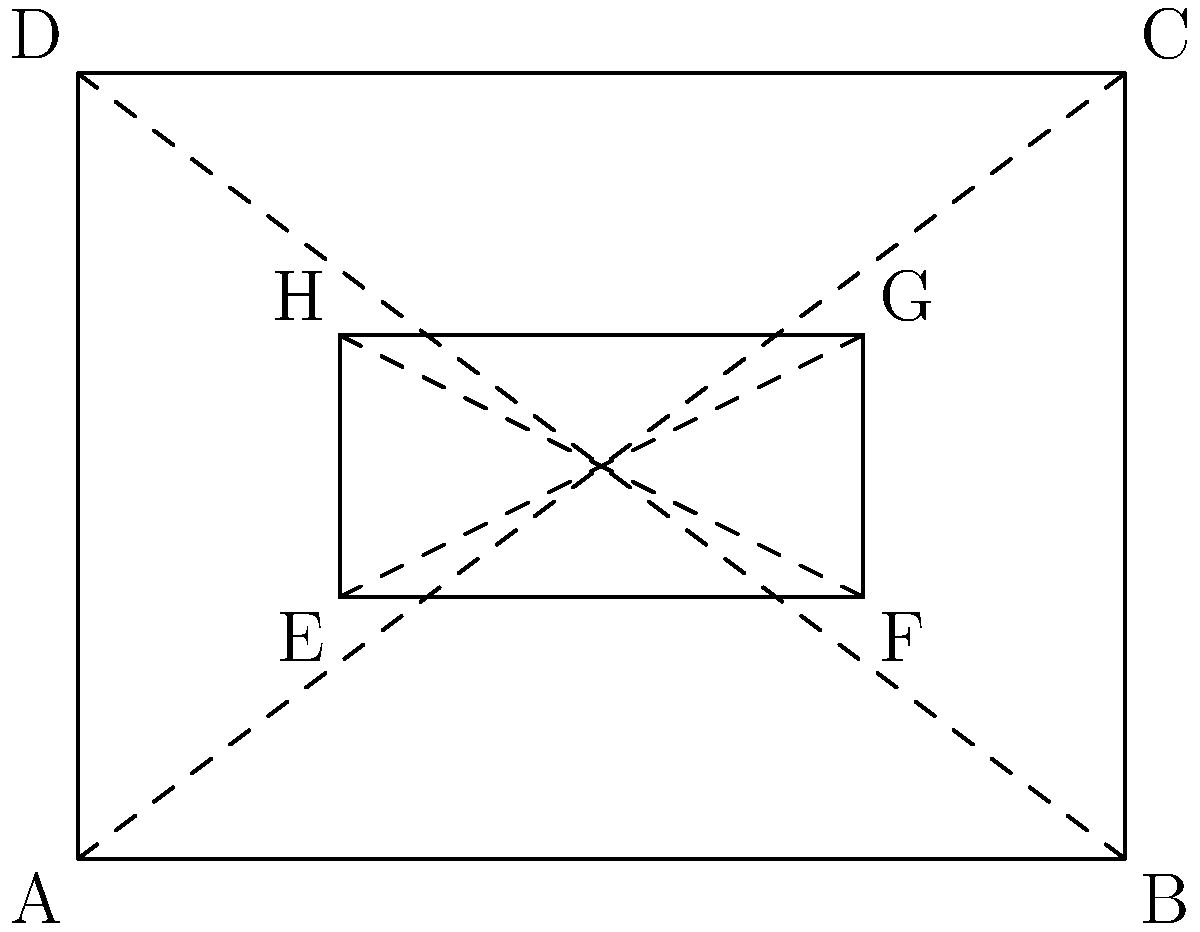In a still life composition, you've arranged two rectangular canvases as shown in the diagram. Rectangle ABCD represents a larger canvas, while rectangle EFGH is a smaller canvas placed within it. If you know that triangles AEB and CGD are congruent, what can you conclude about the position of the smaller canvas EFGH within the larger canvas ABCD? Let's approach this step-by-step:

1) First, we need to understand what it means for triangles AEB and CGD to be congruent. This implies that these triangles have equal sides and equal angles.

2) In rectangle ABCD, AC and BD are diagonals. They intersect at the center of the rectangle and bisect each other.

3) Similarly, in rectangle EFGH, EG and FH are diagonals that intersect at the center of this smaller rectangle.

4) The congruence of triangles AEB and CGD implies that:
   - AE = CG
   - EB = GD
   - Angle AEB = Angle CGD

5) This congruence can only occur if E and G are equidistant from A and C respectively, and similarly, if F and H are equidistant from B and D respectively.

6) For this to be true, the center of rectangle EFGH must coincide with the center of rectangle ABCD.

7) In other words, the diagonals of both rectangles must intersect at the same point, which is the center of both rectangles.

Therefore, we can conclude that the smaller canvas EFGH is centered within the larger canvas ABCD.
Answer: The smaller canvas EFGH is centered within the larger canvas ABCD. 